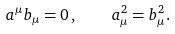<formula> <loc_0><loc_0><loc_500><loc_500>a ^ { \mu } b _ { \mu } = 0 \, , \quad a _ { \mu } ^ { 2 } = b _ { \mu } ^ { 2 } .</formula> 